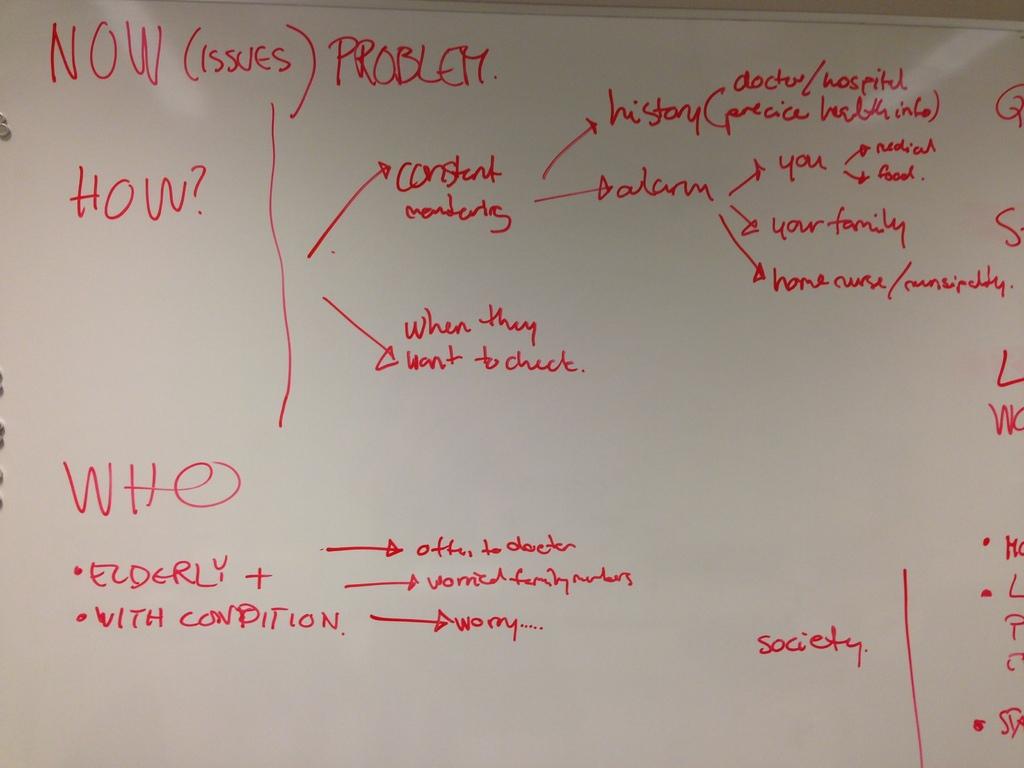What is the word on the bottom right of the page?
Your answer should be very brief. Society. What is on the white board?
Provide a short and direct response. Unanswerable. 